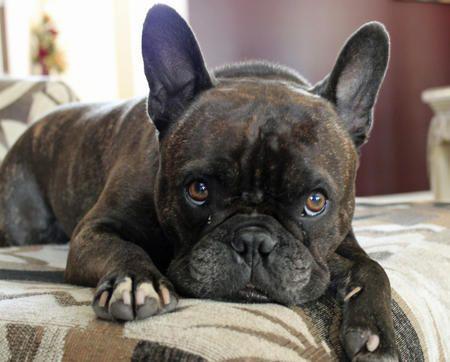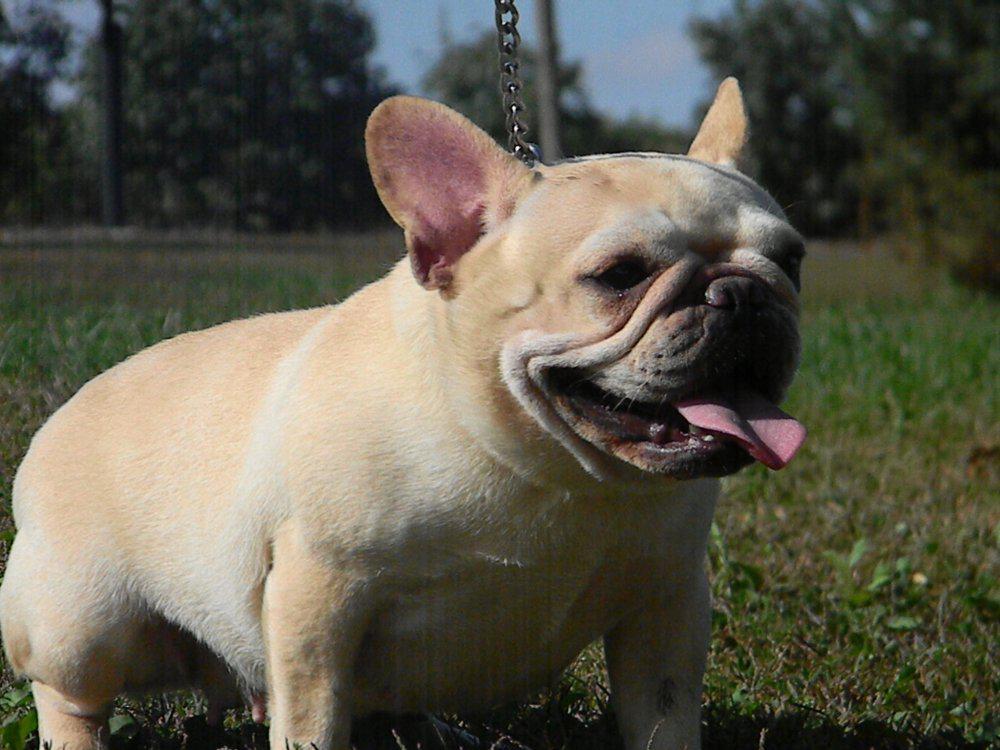The first image is the image on the left, the second image is the image on the right. Given the left and right images, does the statement "One dog has its tongue out." hold true? Answer yes or no. Yes. The first image is the image on the left, the second image is the image on the right. Analyze the images presented: Is the assertion "In one of the images a dog is wearing an object." valid? Answer yes or no. No. 